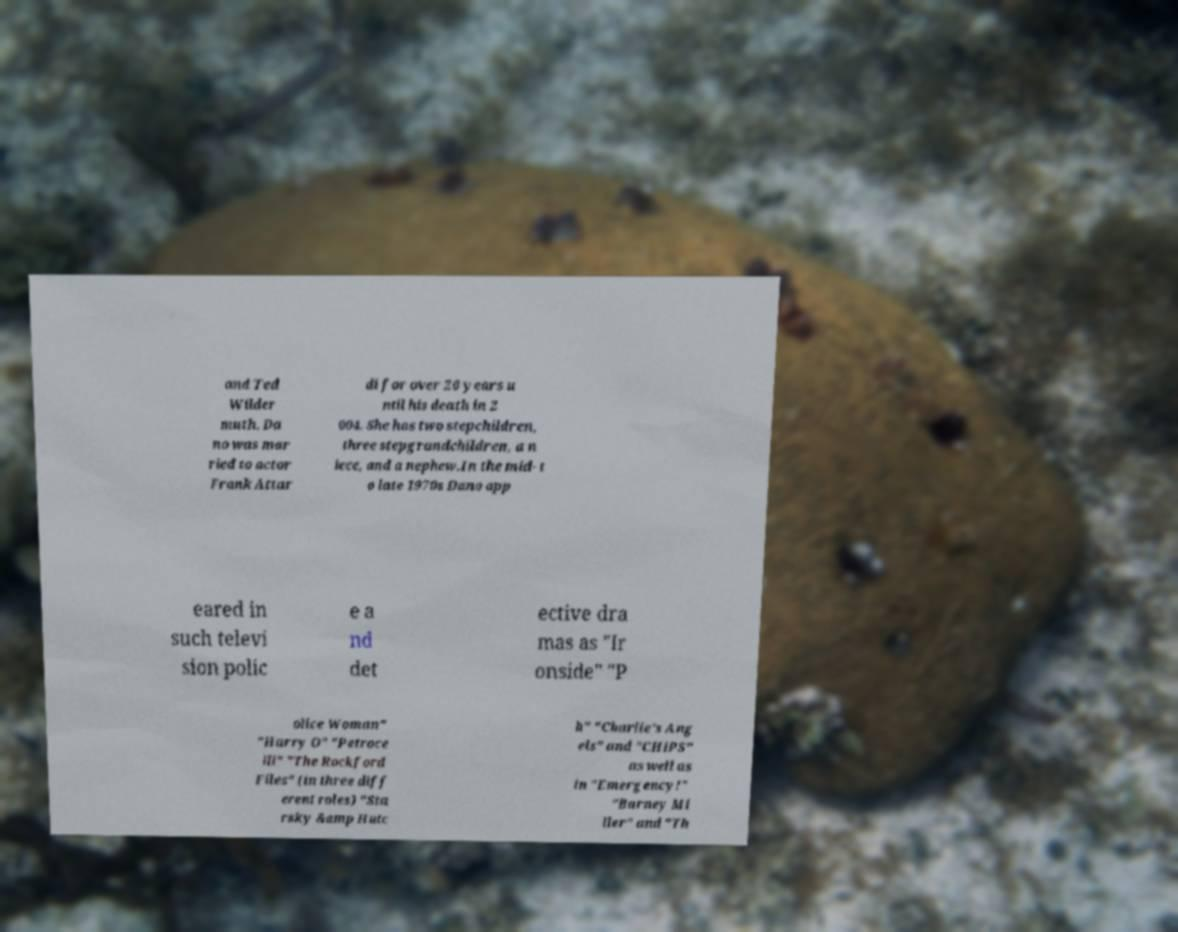Could you assist in decoding the text presented in this image and type it out clearly? and Ted Wilder muth. Da no was mar ried to actor Frank Attar di for over 20 years u ntil his death in 2 004. She has two stepchildren, three stepgrandchildren, a n iece, and a nephew.In the mid- t o late 1970s Dano app eared in such televi sion polic e a nd det ective dra mas as "Ir onside" "P olice Woman" "Harry O" "Petroce lli" "The Rockford Files" (in three diff erent roles) "Sta rsky &amp Hutc h" "Charlie's Ang els" and "CHiPS" as well as in "Emergency!" "Barney Mi ller" and "Th 